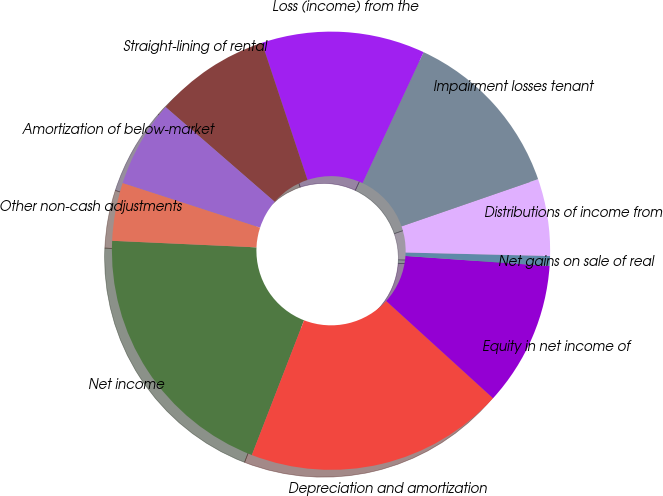Convert chart to OTSL. <chart><loc_0><loc_0><loc_500><loc_500><pie_chart><fcel>Net income<fcel>Depreciation and amortization<fcel>Equity in net income of<fcel>Net gains on sale of real<fcel>Distributions of income from<fcel>Impairment losses tenant<fcel>Loss (income) from the<fcel>Straight-lining of rental<fcel>Amortization of below-market<fcel>Other non-cash adjustments<nl><fcel>19.84%<fcel>19.13%<fcel>10.64%<fcel>0.73%<fcel>5.68%<fcel>12.76%<fcel>12.05%<fcel>8.51%<fcel>6.39%<fcel>4.27%<nl></chart> 